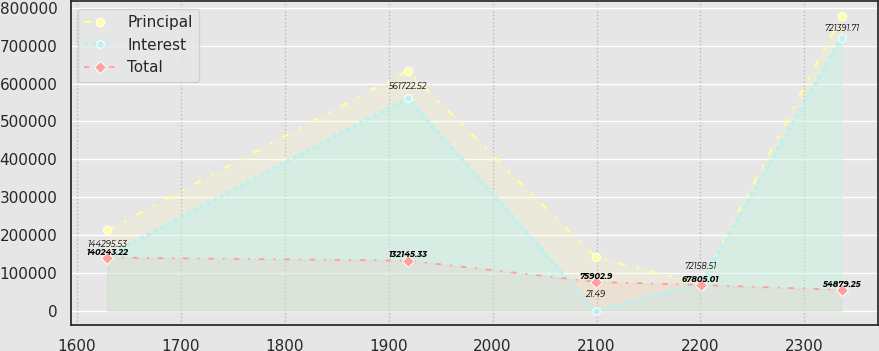Convert chart. <chart><loc_0><loc_0><loc_500><loc_500><line_chart><ecel><fcel>Principal<fcel>Interest<fcel>Total<nl><fcel>1629.26<fcel>212024<fcel>144296<fcel>140243<nl><fcel>1918.28<fcel>633826<fcel>561723<fcel>132145<nl><fcel>2099.18<fcel>141226<fcel>21.49<fcel>75902.9<nl><fcel>2200.14<fcel>70427.4<fcel>72158.5<fcel>67805<nl><fcel>2335.74<fcel>778408<fcel>721392<fcel>54879.2<nl></chart> 